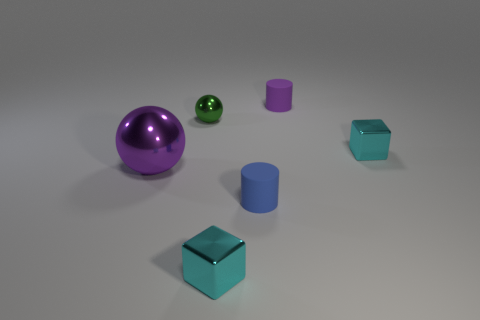What color is the large thing? The largest object in the image is a sphere with a reflective purple surface. 